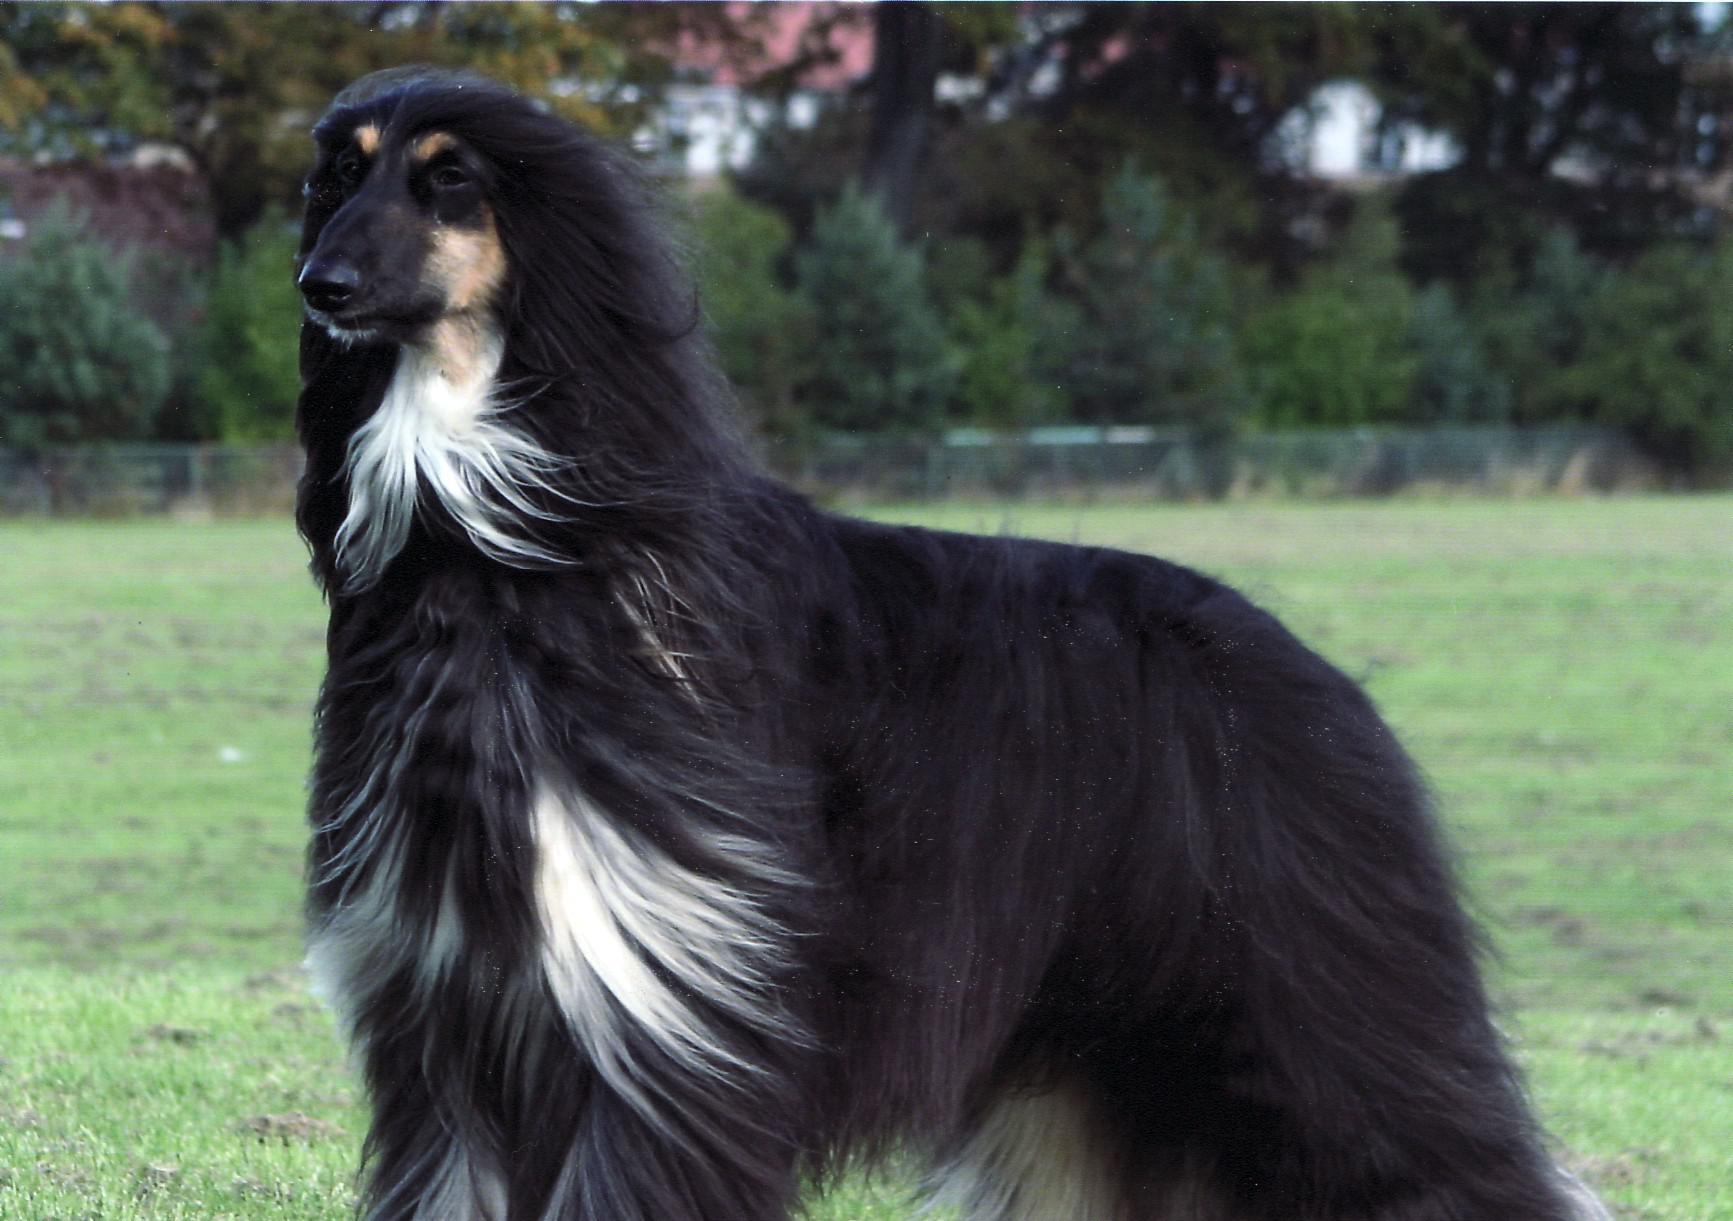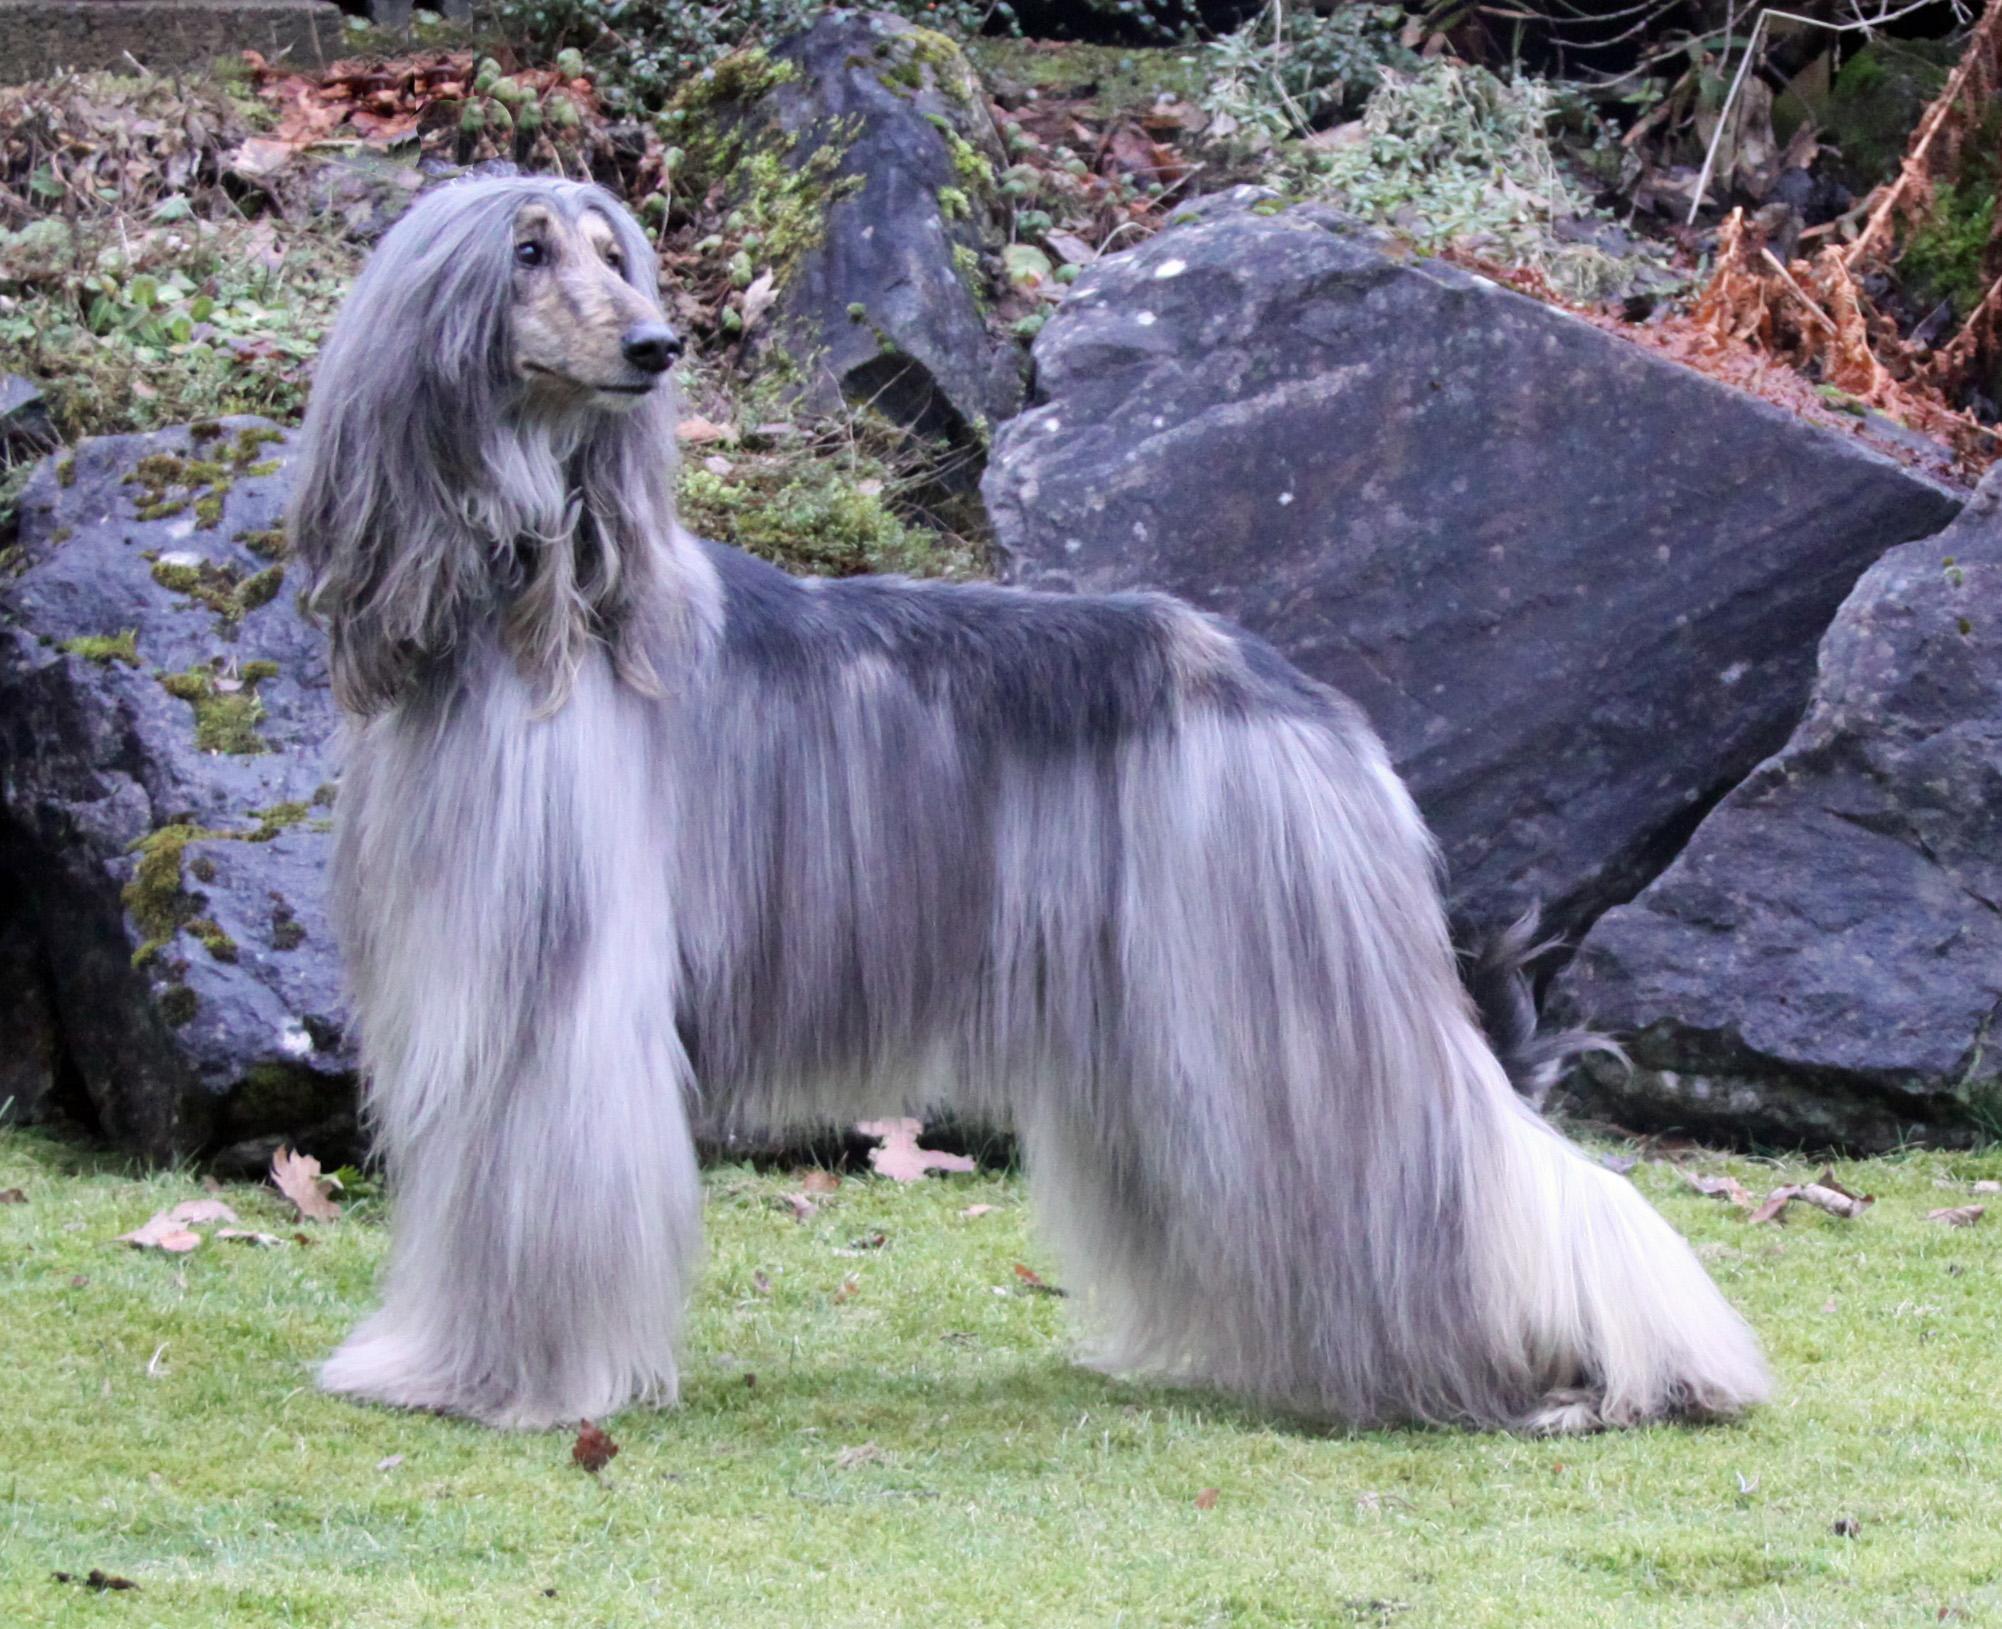The first image is the image on the left, the second image is the image on the right. For the images displayed, is the sentence "Exactly one dog is on the grass." factually correct? Answer yes or no. No. 